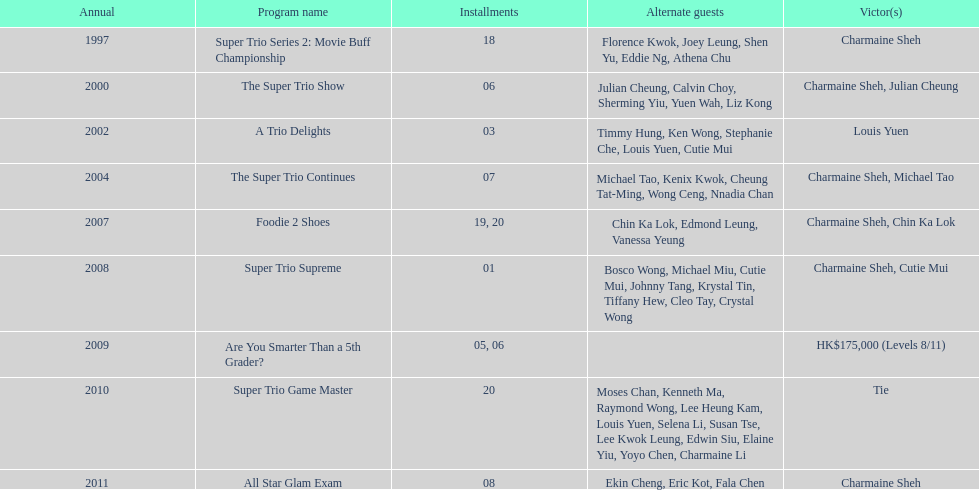How many consecutive trio shows did charmaine sheh do before being on another variety program? 34. 